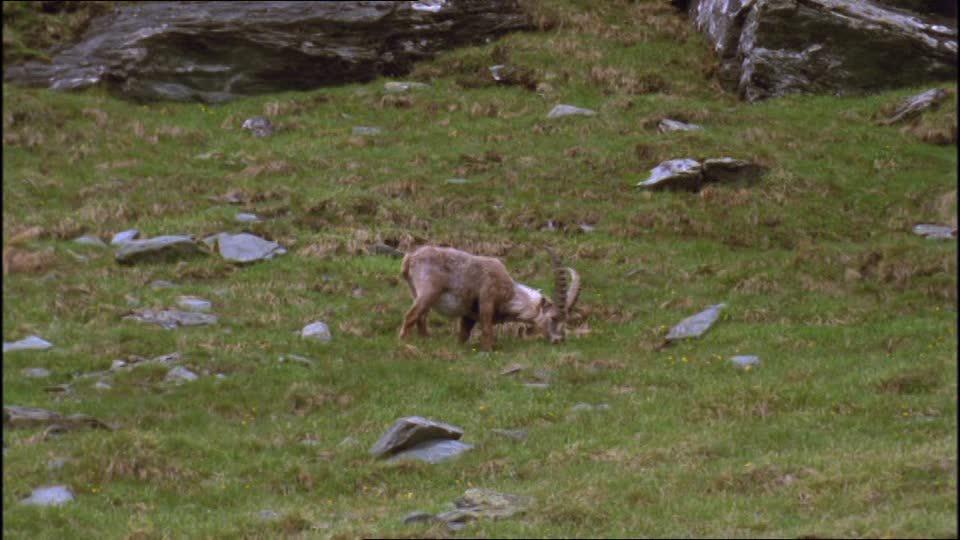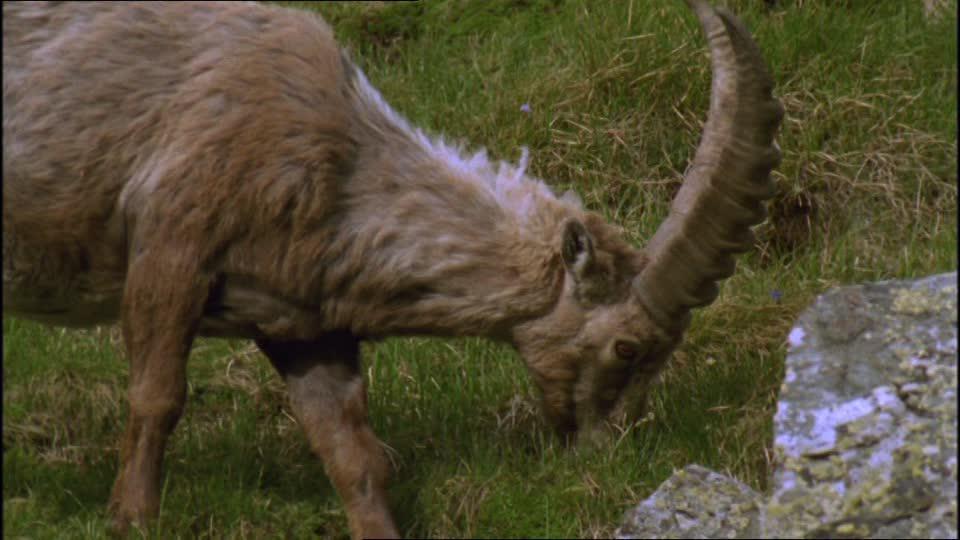The first image is the image on the left, the second image is the image on the right. Examine the images to the left and right. Is the description "The right image shows a ram next to rocks." accurate? Answer yes or no. Yes. The first image is the image on the left, the second image is the image on the right. Analyze the images presented: Is the assertion "Each imagine is one animal facing to the right" valid? Answer yes or no. Yes. 